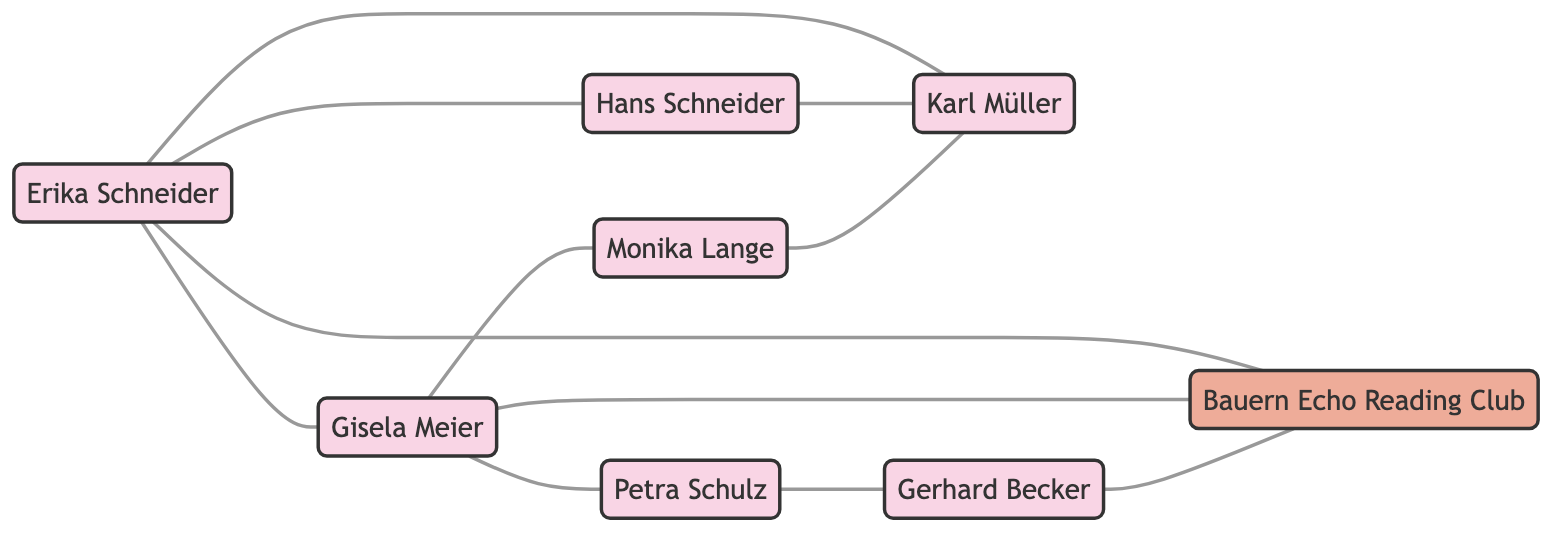What is the relationship between Erika Schneider and Hans Schneider? The diagram shows a direct edge connecting Erika Schneider and Hans Schneider, labeled as "Spouse." This indicates their relationship.
Answer: Spouse Who are the friends of Gisela Meier? The connections from Gisela Meier reveal two edges: one to Petra Schulz labeled "Sister" and another to Monika Lange labeled "Colleague." However, in the context of friendships, she is not directly linked as a friend to either, so only her connections can be interpreted from the diagram.
Answer: None How many members are part of the Bauern Echo Reading Club? The edges connected to the Bauern Echo Reading Club show three nodes linked to it: Erika Schneider, Gisela Meier, and Gerhard Becker, indicating that there are three members.
Answer: 3 Who is the neighbor of Erika Schneider? The diagram shows an edge connecting Erika Schneider to Karl Müller, indicating their relationship as a neighbor. This is a straightforward connection that can be identified by looking at Erika's edges.
Answer: Karl Müller How many total persons are represented in the diagram? By counting the nodes identified as "Person," we find there are seven: Erika Schneider, Hans Schneider, Gisela Meier, Karl Müller, Petra Schulz, Gerhard Becker, and Monika Lange. This requires totaling the nodes listed as types "Person."
Answer: 7 Which two individuals are connected through friendship? The diagram has multiple edges indicating friendships, but those directly linked as "Friend" are Erika Schneider & Hans Schneider, and also Monika Lange & Karl Müller. We can find these by reviewing the edges for the specific relationship of "Friend."
Answer: Erika Schneider and Hans Schneider; Monika Lange and Karl Müller Which individual has the most connections in the network? To find this, we can assess the number of edges connected to each node. Gisela Meier has 4 connections (Sister, Colleague, Member), while others have fewer. Thus, the one with the most connections is identified through counting.
Answer: Gisela Meier What type of connection exists between Gisela Meier and Petra Schulz? They are directly connected by an edge labeled "Sister." This specific relationship can be identified by looking at the edge connecting them and noting the label provided.
Answer: Sister How many edges are there in the social network graph? By counting all the relationships (edges) listed in the edges section, we find eight edges total: each representing a connection among the people, including group memberships.
Answer: 10 